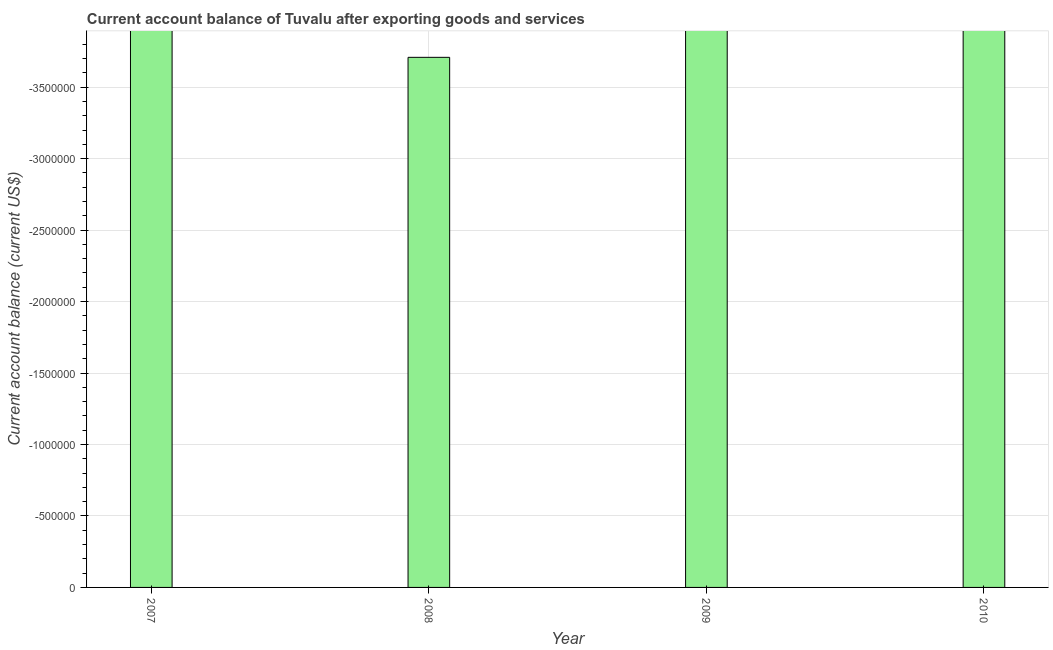Does the graph contain any zero values?
Keep it short and to the point. Yes. Does the graph contain grids?
Ensure brevity in your answer.  Yes. What is the title of the graph?
Provide a succinct answer. Current account balance of Tuvalu after exporting goods and services. What is the label or title of the Y-axis?
Provide a succinct answer. Current account balance (current US$). What is the sum of the current account balance?
Make the answer very short. 0. What is the median current account balance?
Give a very brief answer. 0. In how many years, is the current account balance greater than -200000 US$?
Ensure brevity in your answer.  0. How many bars are there?
Keep it short and to the point. 0. How many years are there in the graph?
Ensure brevity in your answer.  4. What is the difference between two consecutive major ticks on the Y-axis?
Your answer should be compact. 5.00e+05. What is the Current account balance (current US$) in 2007?
Provide a succinct answer. 0. 